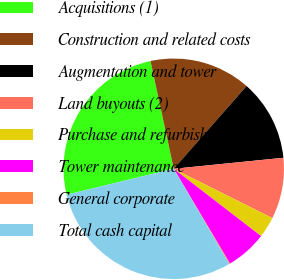Convert chart to OTSL. <chart><loc_0><loc_0><loc_500><loc_500><pie_chart><fcel>Acquisitions (1)<fcel>Construction and related costs<fcel>Augmentation and tower<fcel>Land buyouts (2)<fcel>Purchase and refurbishment of<fcel>Tower maintenance<fcel>General corporate<fcel>Total cash capital<nl><fcel>25.4%<fcel>14.87%<fcel>11.92%<fcel>8.97%<fcel>3.07%<fcel>6.02%<fcel>0.12%<fcel>29.63%<nl></chart> 